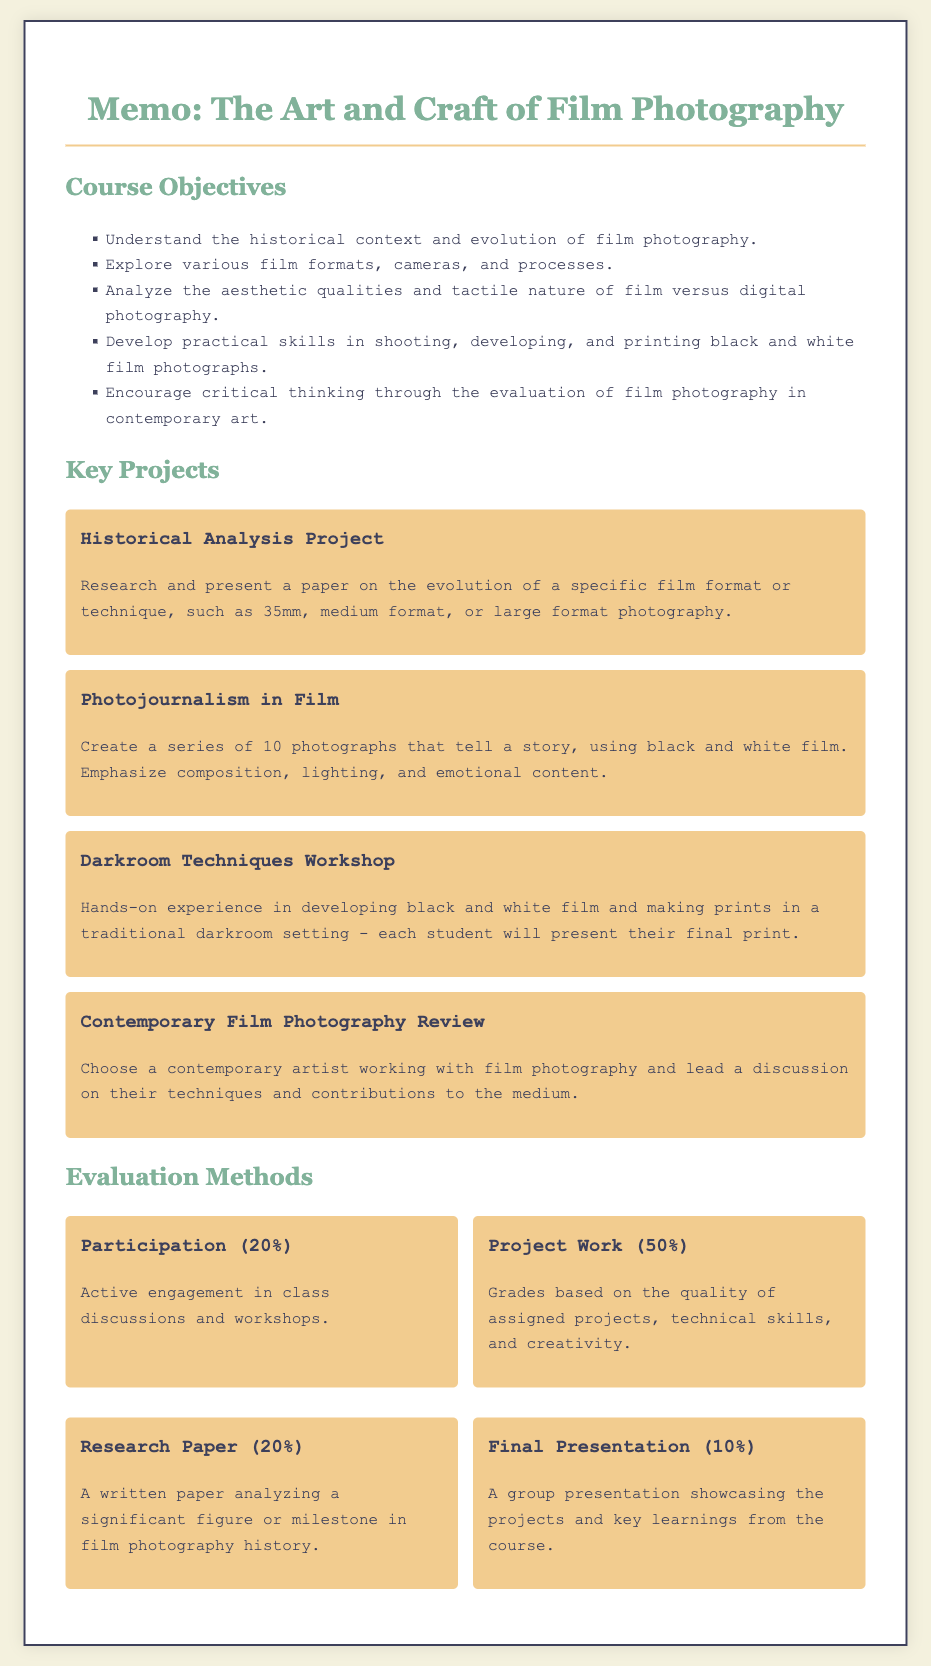What are the main objectives of the course? The objectives are listed in the "Course Objectives" section of the memo.
Answer: Understand the historical context and evolution of film photography, Explore various film formats, cameras, and processes, Analyze the aesthetic qualities and tactile nature of film versus digital photography, Develop practical skills in shooting, developing, and printing black and white film photographs, Encourage critical thinking through the evaluation of film photography in contemporary art What percentage of the evaluation is based on project work? The percentage is specified in the "Evaluation Methods" section.
Answer: 50% What is the focus of the "Photojournalism in Film" project? The focus is described in the project summary.
Answer: Create a series of 10 photographs that tell a story, using black and white film Which project involves hands-on experience in the darkroom? The project description indicates which one focuses on practical skills.
Answer: Darkroom Techniques Workshop What is the weight of the final presentation in the overall evaluation? The weight is stated in the "Evaluation Methods" section.
Answer: 10% Who should lead the discussion in the "Contemporary Film Photography Review" project? The summary provides clarification on who leads the discussion.
Answer: The student 